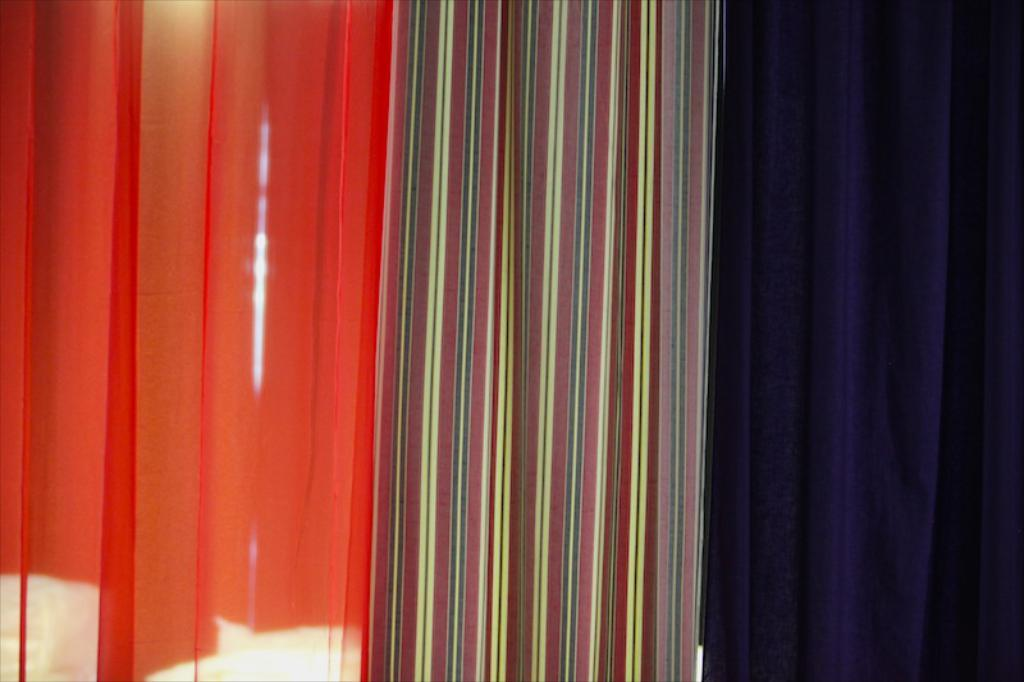What type of objects are present in the image? There are three colorful clothes in the image. Can you describe the appearance of the clothes? The clothes are colorful, but the specific colors are not mentioned in the facts. Are there any other objects or people in the image? The facts only mention the presence of three colorful clothes, so no other objects or people are mentioned. Is there a throne made of berries in the image? No, there is no throne or berries mentioned in the image. The image only contains three colorful clothes. 